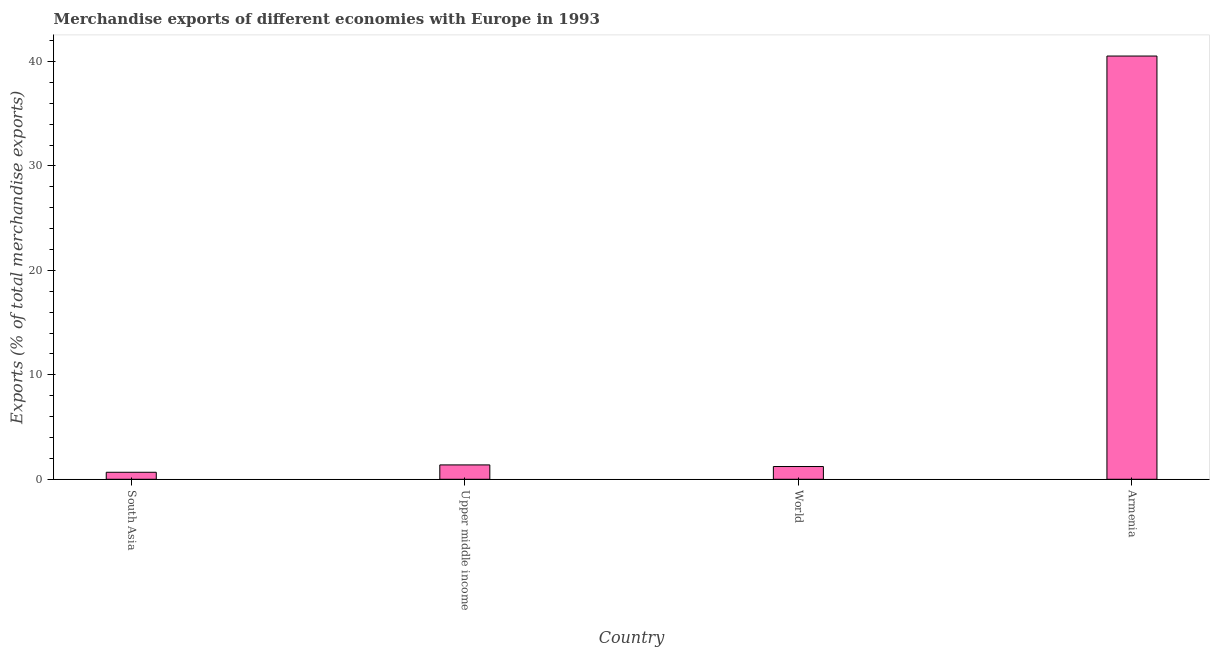Does the graph contain grids?
Ensure brevity in your answer.  No. What is the title of the graph?
Keep it short and to the point. Merchandise exports of different economies with Europe in 1993. What is the label or title of the X-axis?
Give a very brief answer. Country. What is the label or title of the Y-axis?
Ensure brevity in your answer.  Exports (% of total merchandise exports). What is the merchandise exports in Upper middle income?
Make the answer very short. 1.37. Across all countries, what is the maximum merchandise exports?
Your response must be concise. 40.52. Across all countries, what is the minimum merchandise exports?
Give a very brief answer. 0.67. In which country was the merchandise exports maximum?
Ensure brevity in your answer.  Armenia. What is the sum of the merchandise exports?
Provide a succinct answer. 43.78. What is the difference between the merchandise exports in Upper middle income and World?
Provide a succinct answer. 0.15. What is the average merchandise exports per country?
Offer a terse response. 10.95. What is the median merchandise exports?
Provide a succinct answer. 1.3. In how many countries, is the merchandise exports greater than 12 %?
Provide a short and direct response. 1. What is the ratio of the merchandise exports in Armenia to that in South Asia?
Provide a short and direct response. 60.45. Is the difference between the merchandise exports in South Asia and Upper middle income greater than the difference between any two countries?
Your answer should be very brief. No. What is the difference between the highest and the second highest merchandise exports?
Ensure brevity in your answer.  39.14. What is the difference between the highest and the lowest merchandise exports?
Your response must be concise. 39.85. How many bars are there?
Your answer should be compact. 4. What is the difference between two consecutive major ticks on the Y-axis?
Provide a succinct answer. 10. Are the values on the major ticks of Y-axis written in scientific E-notation?
Make the answer very short. No. What is the Exports (% of total merchandise exports) of South Asia?
Make the answer very short. 0.67. What is the Exports (% of total merchandise exports) in Upper middle income?
Make the answer very short. 1.37. What is the Exports (% of total merchandise exports) of World?
Give a very brief answer. 1.22. What is the Exports (% of total merchandise exports) of Armenia?
Make the answer very short. 40.52. What is the difference between the Exports (% of total merchandise exports) in South Asia and Upper middle income?
Your answer should be compact. -0.7. What is the difference between the Exports (% of total merchandise exports) in South Asia and World?
Offer a terse response. -0.55. What is the difference between the Exports (% of total merchandise exports) in South Asia and Armenia?
Offer a terse response. -39.85. What is the difference between the Exports (% of total merchandise exports) in Upper middle income and World?
Provide a succinct answer. 0.15. What is the difference between the Exports (% of total merchandise exports) in Upper middle income and Armenia?
Provide a succinct answer. -39.14. What is the difference between the Exports (% of total merchandise exports) in World and Armenia?
Your response must be concise. -39.3. What is the ratio of the Exports (% of total merchandise exports) in South Asia to that in Upper middle income?
Provide a short and direct response. 0.49. What is the ratio of the Exports (% of total merchandise exports) in South Asia to that in World?
Provide a short and direct response. 0.55. What is the ratio of the Exports (% of total merchandise exports) in South Asia to that in Armenia?
Make the answer very short. 0.02. What is the ratio of the Exports (% of total merchandise exports) in Upper middle income to that in Armenia?
Your answer should be very brief. 0.03. What is the ratio of the Exports (% of total merchandise exports) in World to that in Armenia?
Provide a short and direct response. 0.03. 